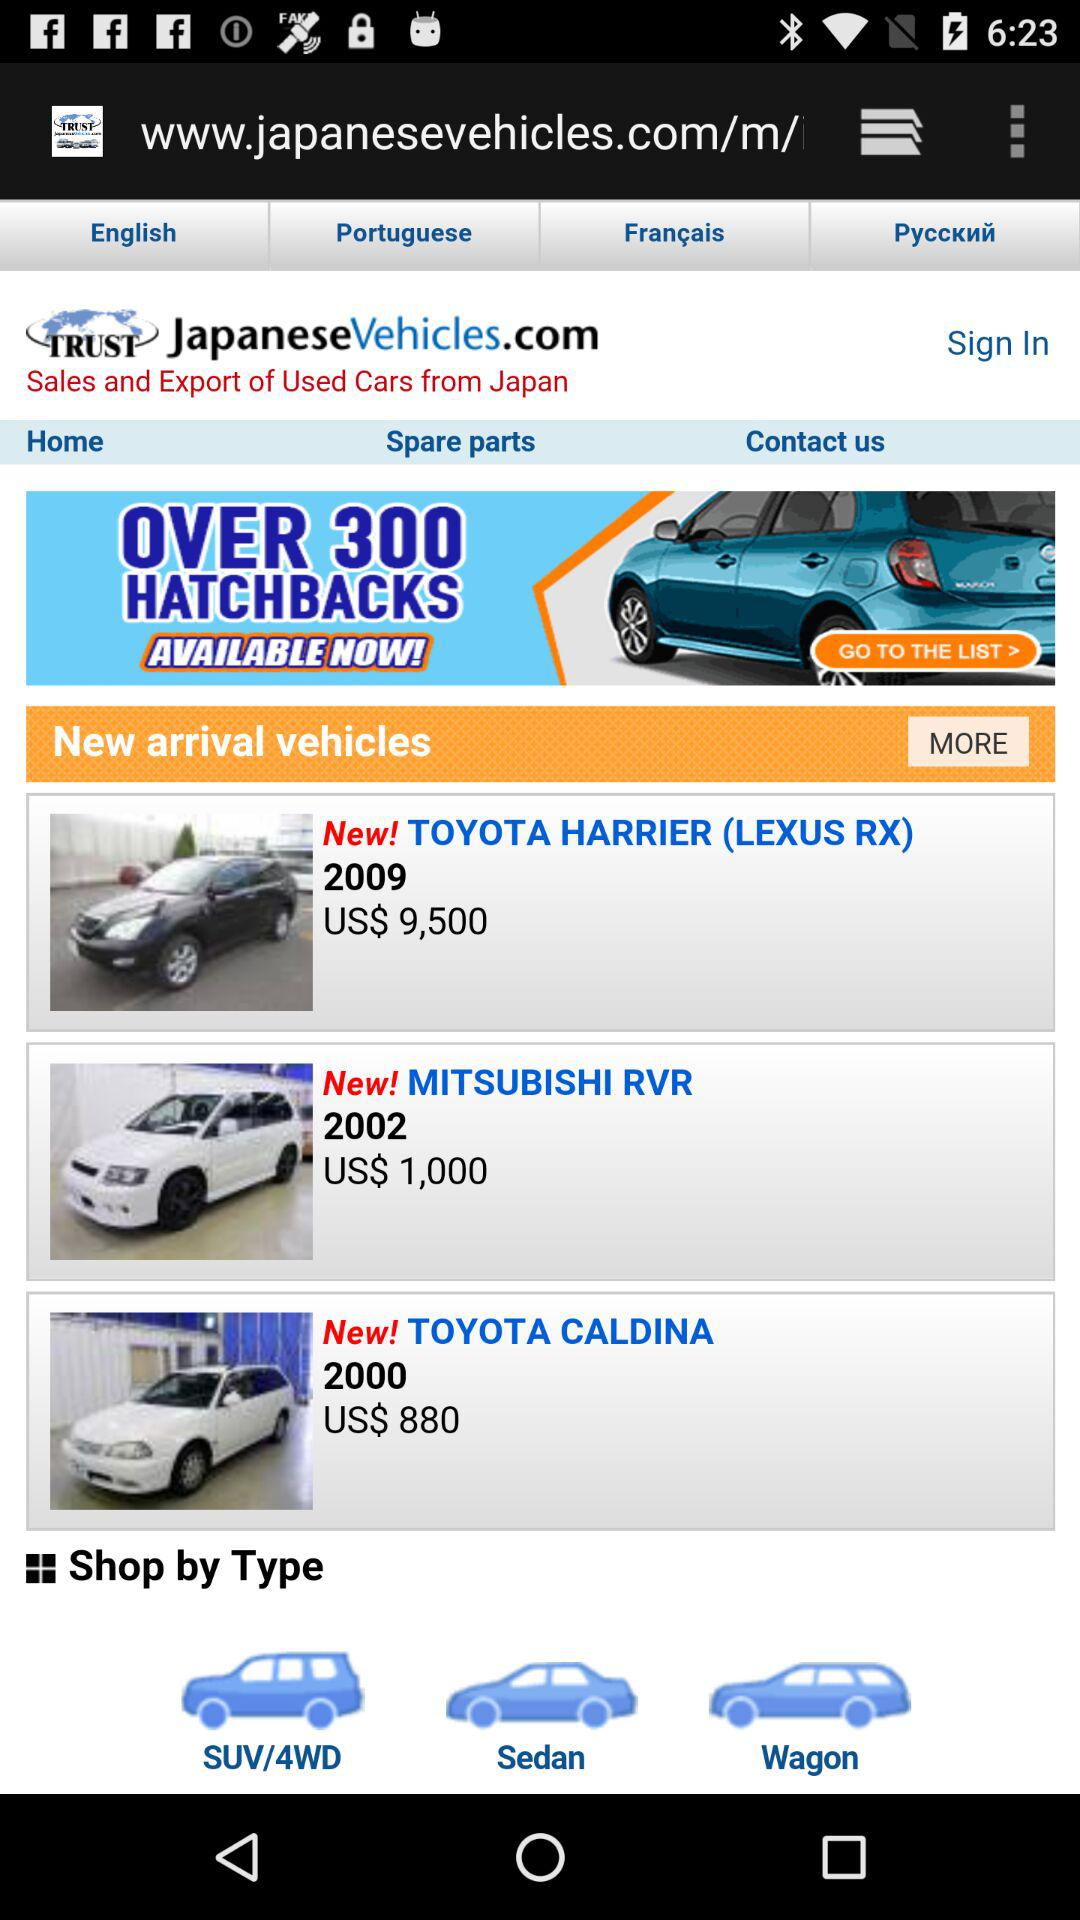What are the new arrivals in vehicles? The new arrivals in vehicles are the "TOYOTA HARRIER (LEXUS RX)", "MITSUBISHI RVR" and "TOYOTA CALDINA". 